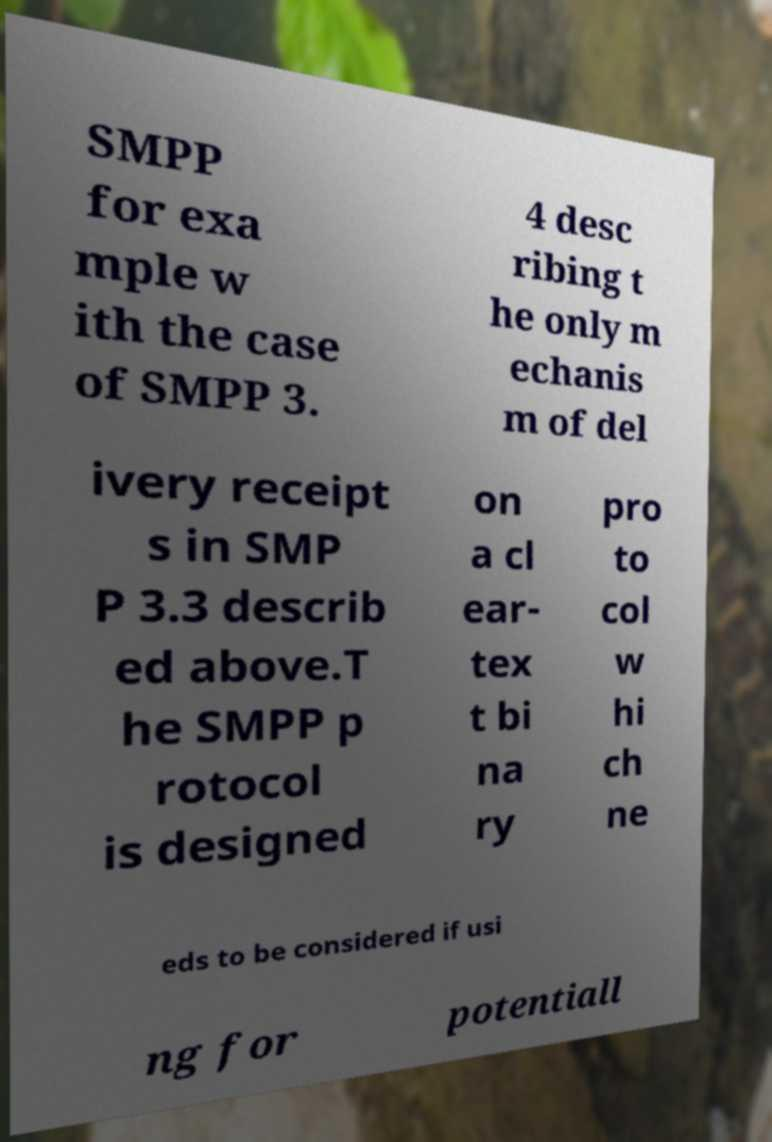I need the written content from this picture converted into text. Can you do that? SMPP for exa mple w ith the case of SMPP 3. 4 desc ribing t he only m echanis m of del ivery receipt s in SMP P 3.3 describ ed above.T he SMPP p rotocol is designed on a cl ear- tex t bi na ry pro to col w hi ch ne eds to be considered if usi ng for potentiall 